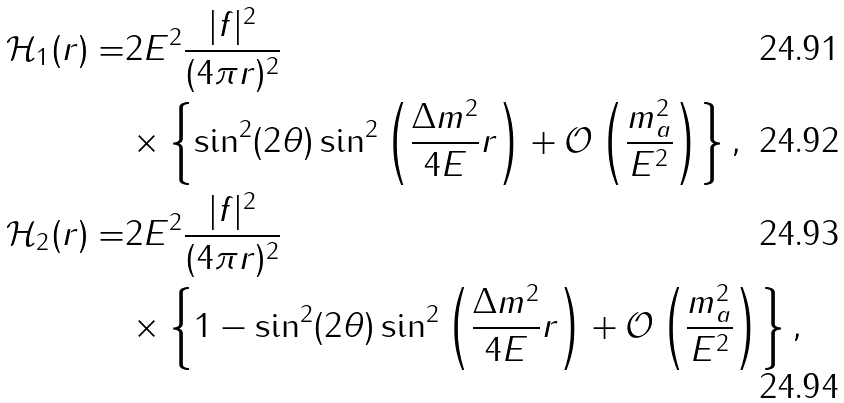<formula> <loc_0><loc_0><loc_500><loc_500>\mathcal { H } _ { 1 } ( r ) = & 2 E ^ { 2 } \frac { | f | ^ { 2 } } { ( 4 \pi r ) ^ { 2 } } \\ & \times \left \{ \sin ^ { 2 } ( 2 \theta ) \sin ^ { 2 } \left ( \frac { \Delta m ^ { 2 } } { 4 E } r \right ) + \mathcal { O } \left ( \frac { m _ { a } ^ { 2 } } { E ^ { 2 } } \right ) \right \} , \\ \mathcal { H } _ { 2 } ( r ) = & 2 E ^ { 2 } \frac { | f | ^ { 2 } } { ( 4 \pi r ) ^ { 2 } } \\ & \times \left \{ 1 - \sin ^ { 2 } ( 2 \theta ) \sin ^ { 2 } \left ( \frac { \Delta m ^ { 2 } } { 4 E } r \right ) + \mathcal { O } \left ( \frac { m _ { a } ^ { 2 } } { E ^ { 2 } } \right ) \right \} ,</formula> 